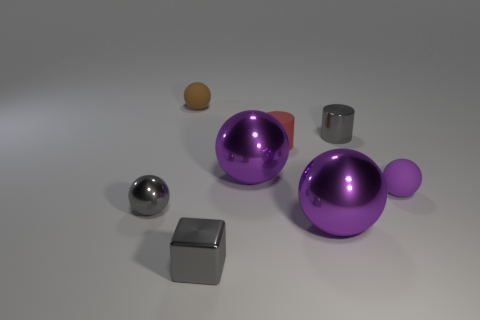What is the color of the sphere that is both left of the small metal cylinder and on the right side of the red cylinder?
Your response must be concise. Purple. What number of small red cylinders are the same material as the cube?
Your answer should be compact. 0. How many gray metal spheres are there?
Offer a very short reply. 1. There is a metallic cylinder; is it the same size as the purple metallic sphere in front of the small purple sphere?
Your answer should be compact. No. What material is the gray object in front of the purple thing that is in front of the small purple sphere?
Provide a succinct answer. Metal. What size is the gray cylinder on the right side of the big metal ball that is in front of the shiny sphere left of the tiny brown sphere?
Provide a short and direct response. Small. Do the brown object and the small red rubber thing on the left side of the gray cylinder have the same shape?
Your answer should be compact. No. What is the small purple thing made of?
Offer a very short reply. Rubber. How many shiny things are tiny gray cylinders or big things?
Offer a terse response. 3. Are there fewer tiny gray shiny spheres left of the gray cylinder than small brown objects behind the tiny red cylinder?
Your answer should be very brief. No. 